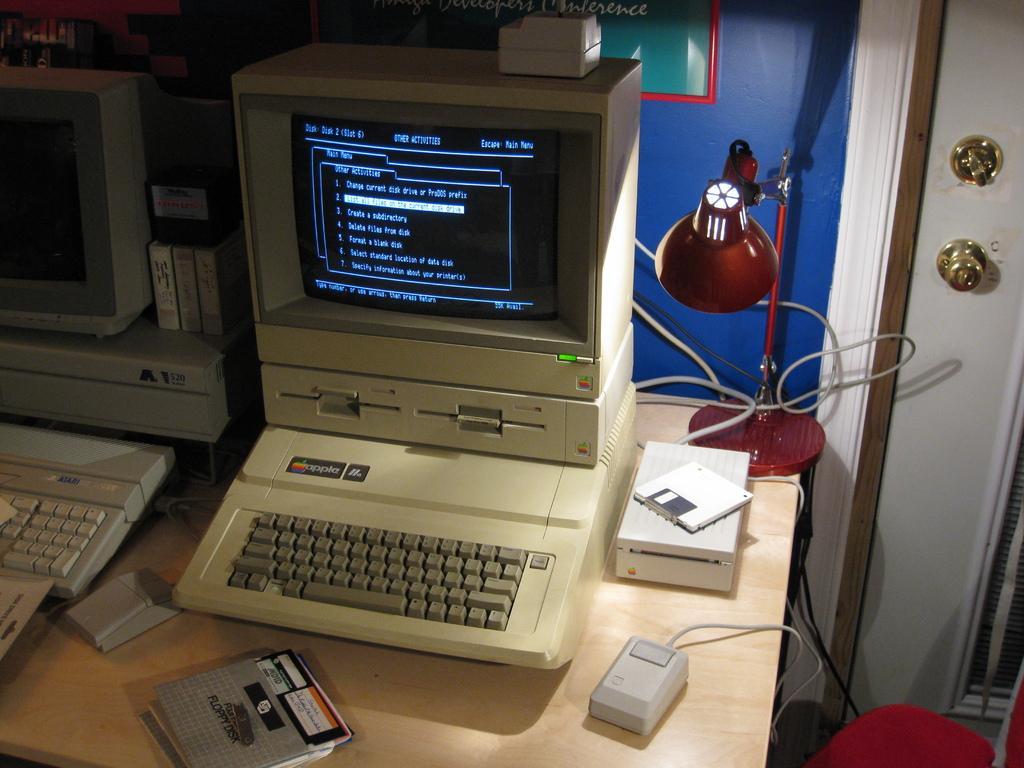How would you summarize this image in a sentence or two? In this picture we can see a table and on the table there are monitors, keyboards, cables and some objects. Behind the monitors there is a wall. On the right side of the table, it looks like a red color chair and behind the chair there is the door. 